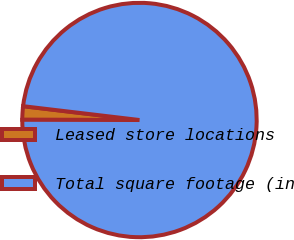<chart> <loc_0><loc_0><loc_500><loc_500><pie_chart><fcel>Leased store locations<fcel>Total square footage (in<nl><fcel>1.85%<fcel>98.15%<nl></chart> 